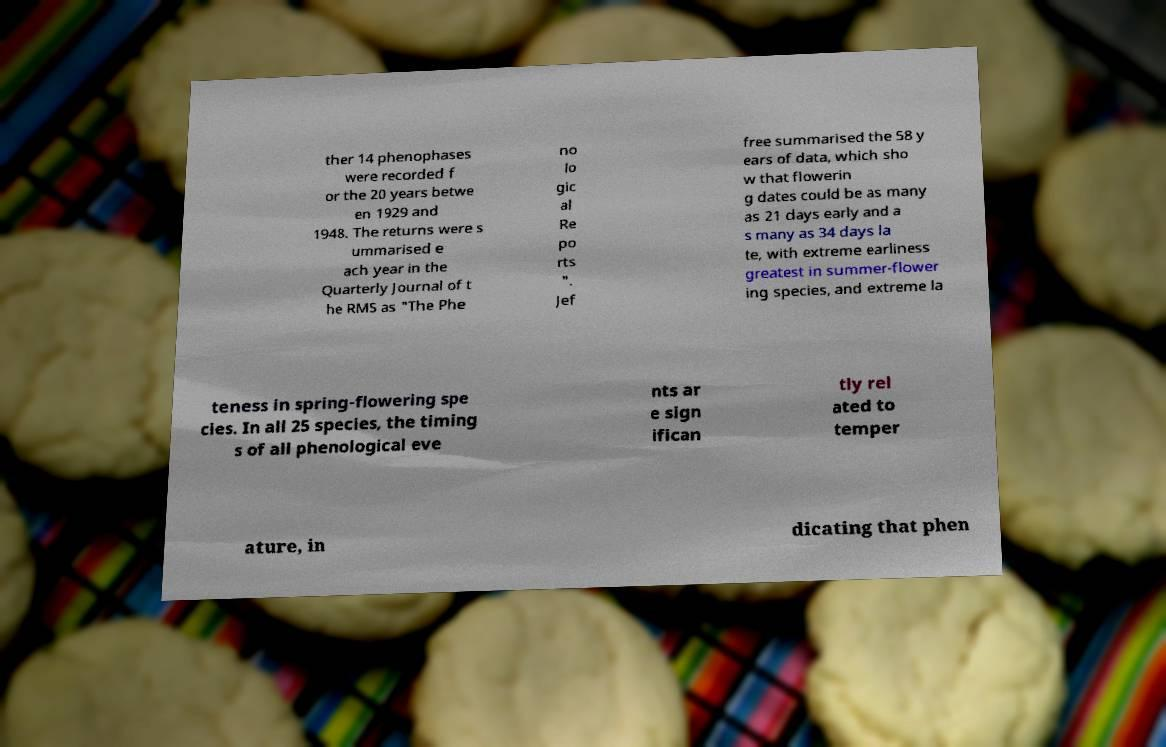I need the written content from this picture converted into text. Can you do that? ther 14 phenophases were recorded f or the 20 years betwe en 1929 and 1948. The returns were s ummarised e ach year in the Quarterly Journal of t he RMS as "The Phe no lo gic al Re po rts ". Jef free summarised the 58 y ears of data, which sho w that flowerin g dates could be as many as 21 days early and a s many as 34 days la te, with extreme earliness greatest in summer-flower ing species, and extreme la teness in spring-flowering spe cies. In all 25 species, the timing s of all phenological eve nts ar e sign ifican tly rel ated to temper ature, in dicating that phen 